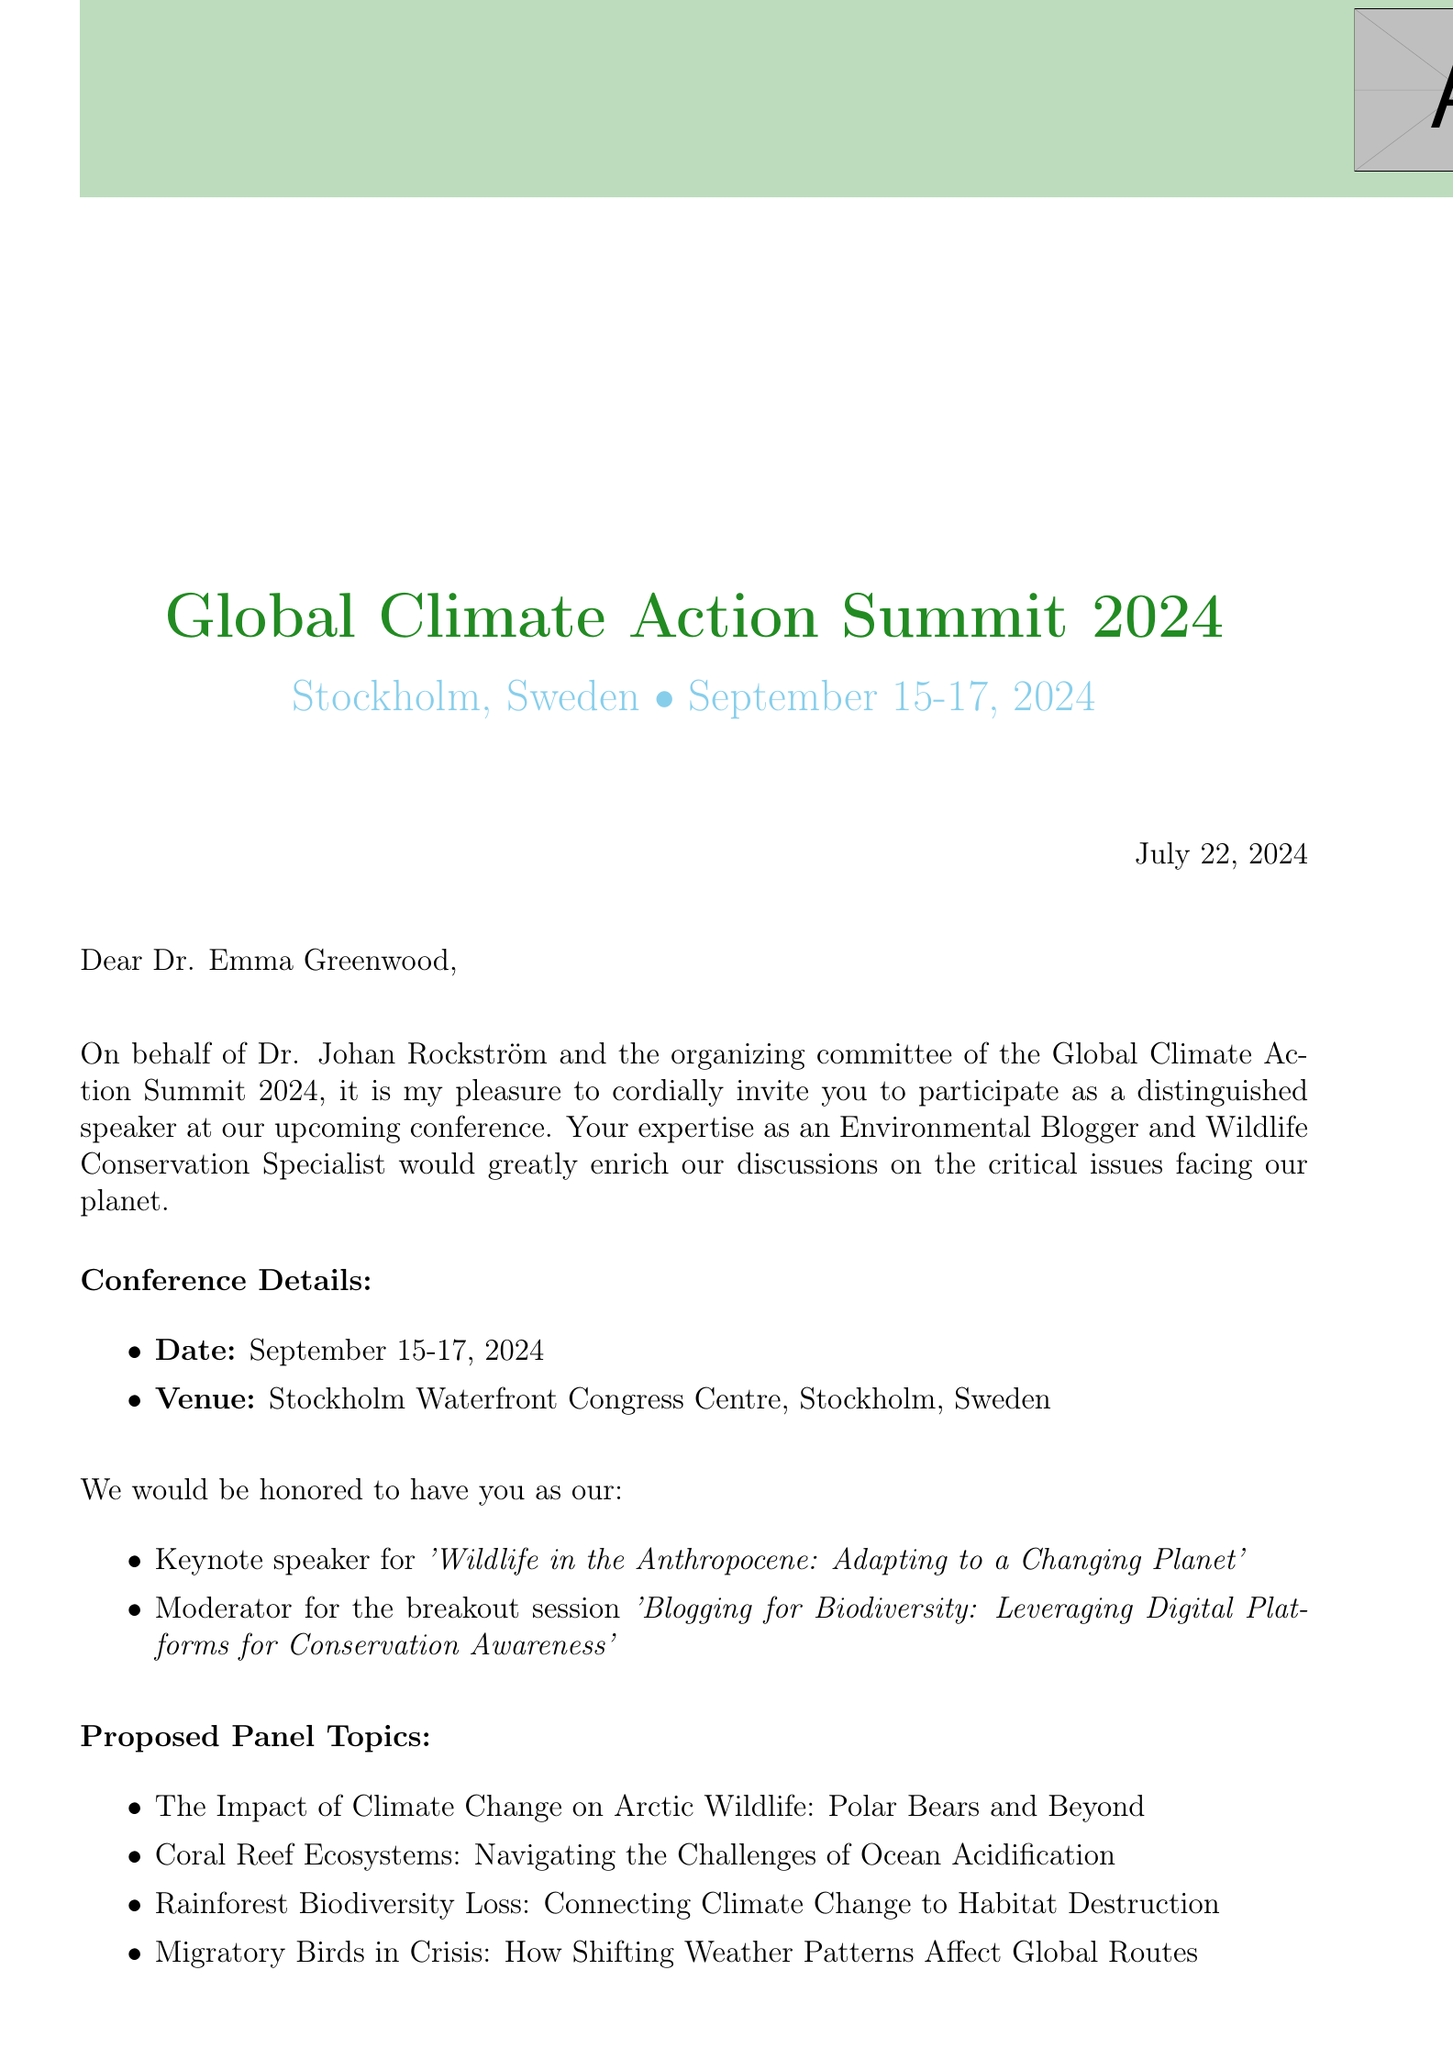What is the name of the conference? The name of the conference is mentioned in the document as the Global Climate Action Summit 2024.
Answer: Global Climate Action Summit 2024 Who is inviting Dr. Emma Greenwood? The document specifies that Dr. Johan Rockström invited Dr. Emma Greenwood.
Answer: Dr. Johan Rockström What dates is the conference scheduled for? The document lists the dates for the conference as September 15-17, 2024.
Answer: September 15-17, 2024 What is the proposed keynote topic? The document states that Dr. Emma Greenwood is invited to be the keynote speaker for 'Wildlife in the Anthropocene: Adapting to a Changing Planet'.
Answer: Wildlife in the Anthropocene: Adapting to a Changing Planet What is the hotel accommodation for the conference? The document indicates that the accommodation will be at the Radisson Blu Waterfront Hotel.
Answer: Radisson Blu Waterfront Hotel When is the confirmation of attendance due? The deadline for the confirmation of attendance is specified as July 1, 2024.
Answer: July 1, 2024 What meal coverage is provided for attendees? The document states that a per diem of €100 for meals and incidentals will be provided.
Answer: €100 per diem What is the dress code for the gala dinner? The document indicates that formal attire is required for the gala dinner.
Answer: Formal attire What is the contact email for the program coordinator? The document provides the email address of the program coordinator, Lisa Svensson, as l.svensson@globalclimateaction.org.
Answer: l.svensson@globalclimateaction.org 